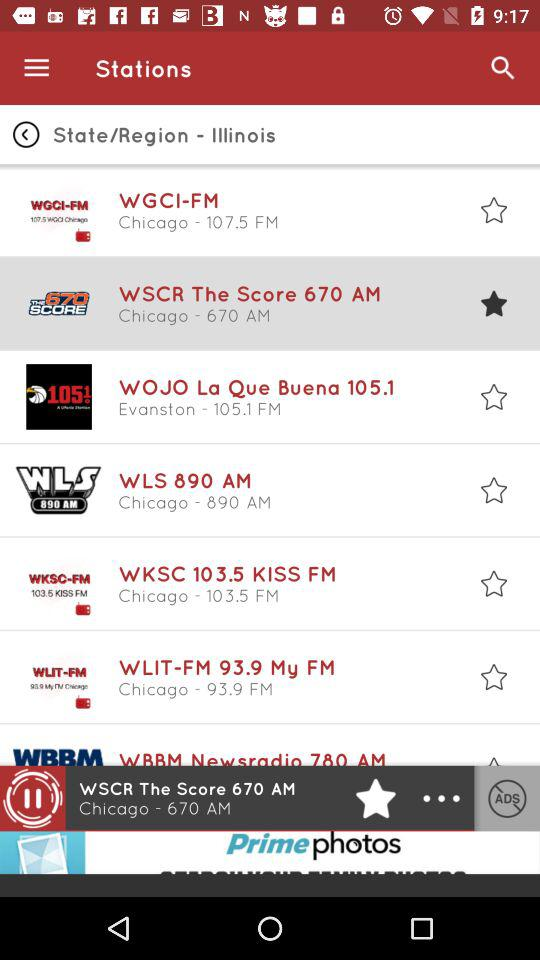What is the application name?
When the provided information is insufficient, respond with <no answer>. <no answer> 